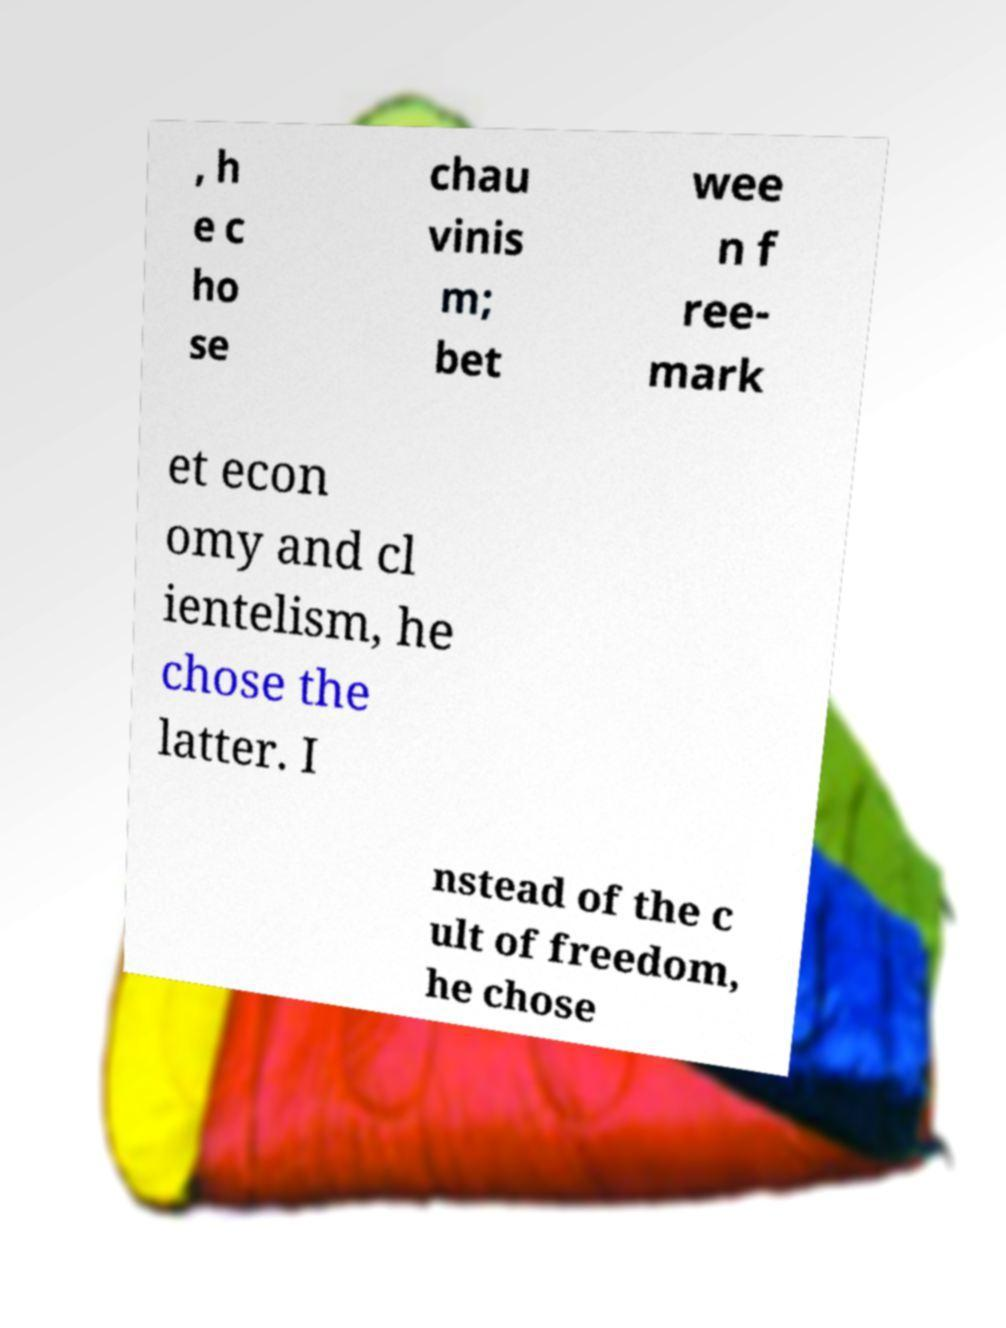Could you extract and type out the text from this image? , h e c ho se chau vinis m; bet wee n f ree- mark et econ omy and cl ientelism, he chose the latter. I nstead of the c ult of freedom, he chose 